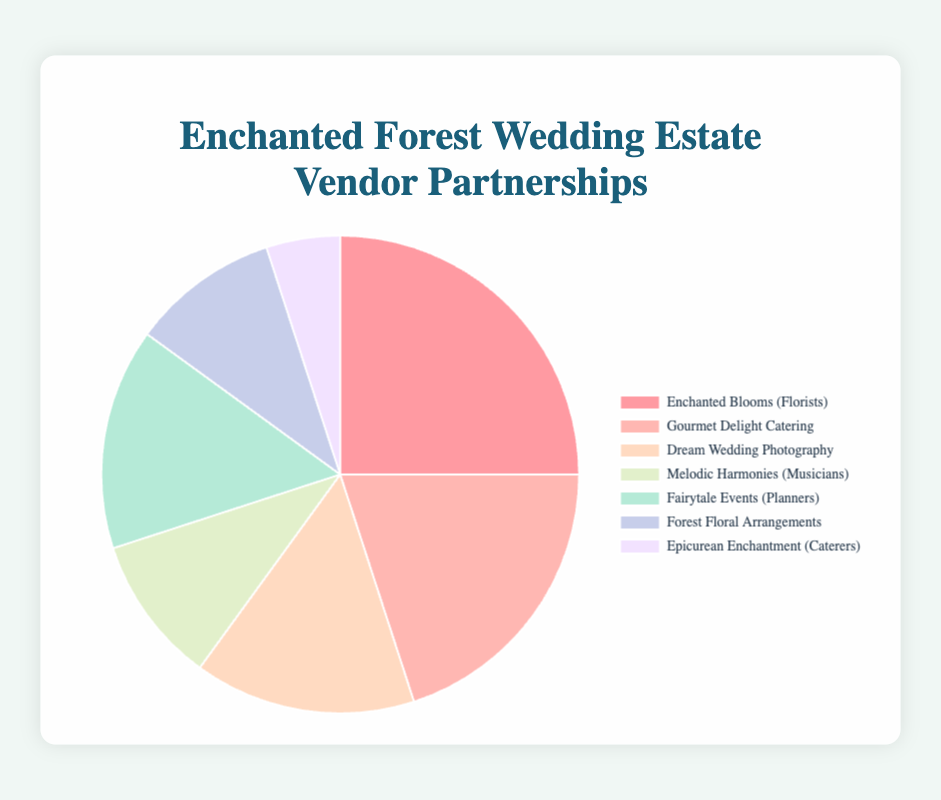Which vendor has the highest partnership percentage? By looking at the pie chart and identifying the largest segment, the vendor with the highest percentage is identifiable. The largest segment corresponds to "Enchanted Blooms (Florists)" with 25%.
Answer: Enchanted Blooms (Florists) How many vendor types have a partnership percentage of 15%? Reviewing the pie chart, you can identify that "Dream Wedding Photography" and "Fairytale Events (Planners)" each have segments comprising 15% of the pie chart. Thus, there are two vendor types with a 15% partnership.
Answer: 2 What is the total partnership percentage for Florists? Add the partnership percentages for all florist vendors. Enchanted Blooms has 25% and Forest Floral Arrangements has 10%, so 25% + 10% = 35%.
Answer: 35% How does the partnership percentage of Melodic Harmonies (Musicians) compare to that of Epicurean Enchantment (Caterers)? According to the pie chart, Melodic Harmonies holds 10% while Epicurean Enchantment holds 5%. Therefore, Melodic Harmonies has a higher partnership percentage.
Answer: Melodic Harmonies (10%) > Epicurean Enchantment (5%) What are the colors representing the two caterers in the pie chart? Observing the pie chart, the segment for "Gourmet Delight Catering" is in a peach tone and "Epicurean Enchantment (Caterers)" is in a lavender tone.
Answer: Peach and lavender What is the combined partnership percentage of all vendors excluding Florists? Subtract the total percentage of florists from 100%. Florists contribute a total of 35%, so 100% - 35% = 65%.
Answer: 65% Which vendor has the second highest partnership percentage and what is it? By examining the sizes of the pie chart segments, the vendor with the second largest segment is "Gourmet Delight Catering" with 20%.
Answer: Gourmet Delight Catering (20%) What is the color of the segment representing Dream Wedding Photography? By looking at the pie chart, the segment corresponding to Dream Wedding Photography is in a light cream or pale yellow color.
Answer: Light cream/pale yellow How much more is the partnership percentage of Gourmet Delight Catering compared to Epicurean Enchantment? Subtract the percentage of Epicurean Enchantment (5%) from Gourmet Delight Catering (20%). So, 20% - 5% = 15%.
Answer: 15% 